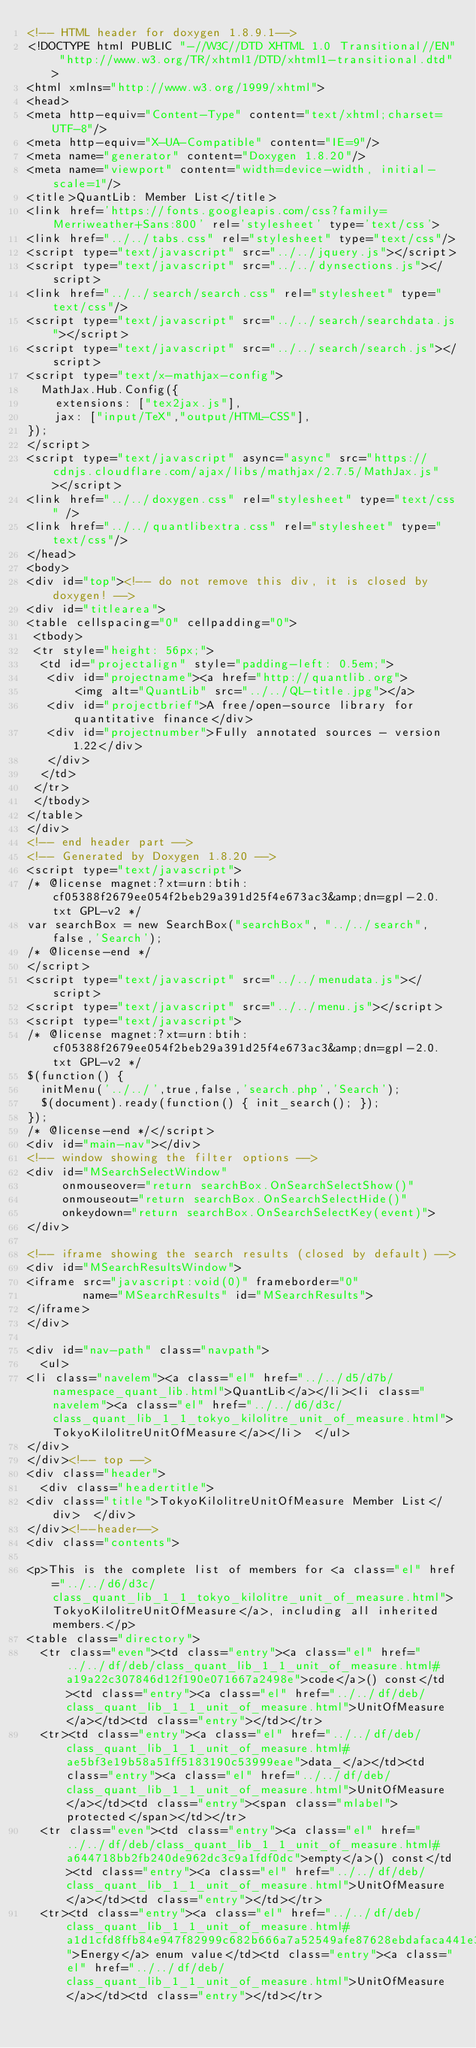Convert code to text. <code><loc_0><loc_0><loc_500><loc_500><_HTML_><!-- HTML header for doxygen 1.8.9.1-->
<!DOCTYPE html PUBLIC "-//W3C//DTD XHTML 1.0 Transitional//EN" "http://www.w3.org/TR/xhtml1/DTD/xhtml1-transitional.dtd">
<html xmlns="http://www.w3.org/1999/xhtml">
<head>
<meta http-equiv="Content-Type" content="text/xhtml;charset=UTF-8"/>
<meta http-equiv="X-UA-Compatible" content="IE=9"/>
<meta name="generator" content="Doxygen 1.8.20"/>
<meta name="viewport" content="width=device-width, initial-scale=1"/>
<title>QuantLib: Member List</title>
<link href='https://fonts.googleapis.com/css?family=Merriweather+Sans:800' rel='stylesheet' type='text/css'>
<link href="../../tabs.css" rel="stylesheet" type="text/css"/>
<script type="text/javascript" src="../../jquery.js"></script>
<script type="text/javascript" src="../../dynsections.js"></script>
<link href="../../search/search.css" rel="stylesheet" type="text/css"/>
<script type="text/javascript" src="../../search/searchdata.js"></script>
<script type="text/javascript" src="../../search/search.js"></script>
<script type="text/x-mathjax-config">
  MathJax.Hub.Config({
    extensions: ["tex2jax.js"],
    jax: ["input/TeX","output/HTML-CSS"],
});
</script>
<script type="text/javascript" async="async" src="https://cdnjs.cloudflare.com/ajax/libs/mathjax/2.7.5/MathJax.js"></script>
<link href="../../doxygen.css" rel="stylesheet" type="text/css" />
<link href="../../quantlibextra.css" rel="stylesheet" type="text/css"/>
</head>
<body>
<div id="top"><!-- do not remove this div, it is closed by doxygen! -->
<div id="titlearea">
<table cellspacing="0" cellpadding="0">
 <tbody>
 <tr style="height: 56px;">
  <td id="projectalign" style="padding-left: 0.5em;">
   <div id="projectname"><a href="http://quantlib.org">
       <img alt="QuantLib" src="../../QL-title.jpg"></a>
   <div id="projectbrief">A free/open-source library for quantitative finance</div>
   <div id="projectnumber">Fully annotated sources - version 1.22</div>
   </div>
  </td>
 </tr>
 </tbody>
</table>
</div>
<!-- end header part -->
<!-- Generated by Doxygen 1.8.20 -->
<script type="text/javascript">
/* @license magnet:?xt=urn:btih:cf05388f2679ee054f2beb29a391d25f4e673ac3&amp;dn=gpl-2.0.txt GPL-v2 */
var searchBox = new SearchBox("searchBox", "../../search",false,'Search');
/* @license-end */
</script>
<script type="text/javascript" src="../../menudata.js"></script>
<script type="text/javascript" src="../../menu.js"></script>
<script type="text/javascript">
/* @license magnet:?xt=urn:btih:cf05388f2679ee054f2beb29a391d25f4e673ac3&amp;dn=gpl-2.0.txt GPL-v2 */
$(function() {
  initMenu('../../',true,false,'search.php','Search');
  $(document).ready(function() { init_search(); });
});
/* @license-end */</script>
<div id="main-nav"></div>
<!-- window showing the filter options -->
<div id="MSearchSelectWindow"
     onmouseover="return searchBox.OnSearchSelectShow()"
     onmouseout="return searchBox.OnSearchSelectHide()"
     onkeydown="return searchBox.OnSearchSelectKey(event)">
</div>

<!-- iframe showing the search results (closed by default) -->
<div id="MSearchResultsWindow">
<iframe src="javascript:void(0)" frameborder="0" 
        name="MSearchResults" id="MSearchResults">
</iframe>
</div>

<div id="nav-path" class="navpath">
  <ul>
<li class="navelem"><a class="el" href="../../d5/d7b/namespace_quant_lib.html">QuantLib</a></li><li class="navelem"><a class="el" href="../../d6/d3c/class_quant_lib_1_1_tokyo_kilolitre_unit_of_measure.html">TokyoKilolitreUnitOfMeasure</a></li>  </ul>
</div>
</div><!-- top -->
<div class="header">
  <div class="headertitle">
<div class="title">TokyoKilolitreUnitOfMeasure Member List</div>  </div>
</div><!--header-->
<div class="contents">

<p>This is the complete list of members for <a class="el" href="../../d6/d3c/class_quant_lib_1_1_tokyo_kilolitre_unit_of_measure.html">TokyoKilolitreUnitOfMeasure</a>, including all inherited members.</p>
<table class="directory">
  <tr class="even"><td class="entry"><a class="el" href="../../df/deb/class_quant_lib_1_1_unit_of_measure.html#a19a22c307846d12f190e071667a2498e">code</a>() const</td><td class="entry"><a class="el" href="../../df/deb/class_quant_lib_1_1_unit_of_measure.html">UnitOfMeasure</a></td><td class="entry"></td></tr>
  <tr><td class="entry"><a class="el" href="../../df/deb/class_quant_lib_1_1_unit_of_measure.html#ae5bf3e19b58a51ff5183190c53999eae">data_</a></td><td class="entry"><a class="el" href="../../df/deb/class_quant_lib_1_1_unit_of_measure.html">UnitOfMeasure</a></td><td class="entry"><span class="mlabel">protected</span></td></tr>
  <tr class="even"><td class="entry"><a class="el" href="../../df/deb/class_quant_lib_1_1_unit_of_measure.html#a644718bb2fb240de962dc3c9a1fdf0dc">empty</a>() const</td><td class="entry"><a class="el" href="../../df/deb/class_quant_lib_1_1_unit_of_measure.html">UnitOfMeasure</a></td><td class="entry"></td></tr>
  <tr><td class="entry"><a class="el" href="../../df/deb/class_quant_lib_1_1_unit_of_measure.html#a1d1cfd8ffb84e947f82999c682b666a7a52549afe87628ebdafaca441e36d0f54">Energy</a> enum value</td><td class="entry"><a class="el" href="../../df/deb/class_quant_lib_1_1_unit_of_measure.html">UnitOfMeasure</a></td><td class="entry"></td></tr></code> 